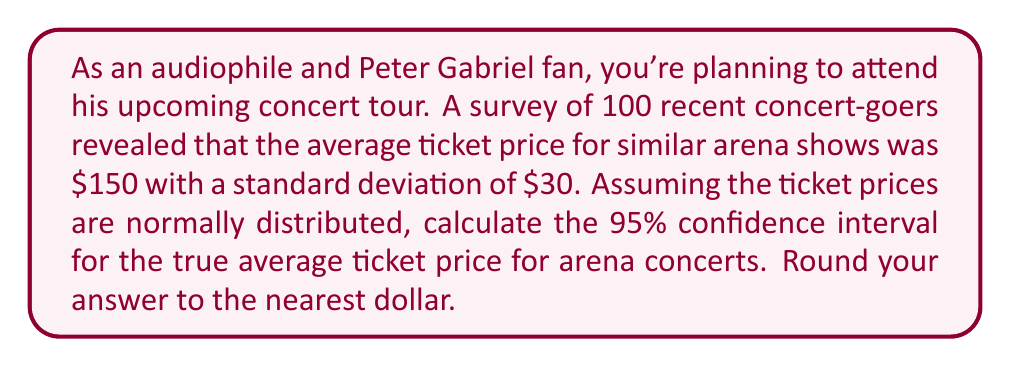Can you solve this math problem? To calculate the confidence interval, we'll use the formula:

$$ \text{CI} = \bar{x} \pm t_{\alpha/2} \cdot \frac{s}{\sqrt{n}} $$

Where:
- $\bar{x}$ is the sample mean ($150)
- $s$ is the sample standard deviation ($30)
- $n$ is the sample size ($100)
- $t_{\alpha/2}$ is the t-value for a 95% confidence interval with $n - 1$ degrees of freedom

Steps:
1) For a 95% CI with 99 degrees of freedom, $t_{\alpha/2} \approx 1.984$ (from t-distribution table)

2) Calculate the standard error of the mean:
   $$ SE = \frac{s}{\sqrt{n}} = \frac{30}{\sqrt{100}} = 3 $$

3) Calculate the margin of error:
   $$ ME = t_{\alpha/2} \cdot SE = 1.984 \cdot 3 = 5.952 $$

4) Calculate the confidence interval:
   $$ \text{CI} = 150 \pm 5.952 $$
   $$ \text{CI} = (144.048, 155.952) $$

5) Rounding to the nearest dollar:
   $$ \text{CI} = (144, 156) $$
Answer: The 95% confidence interval for the true average ticket price is ($144, $156). 